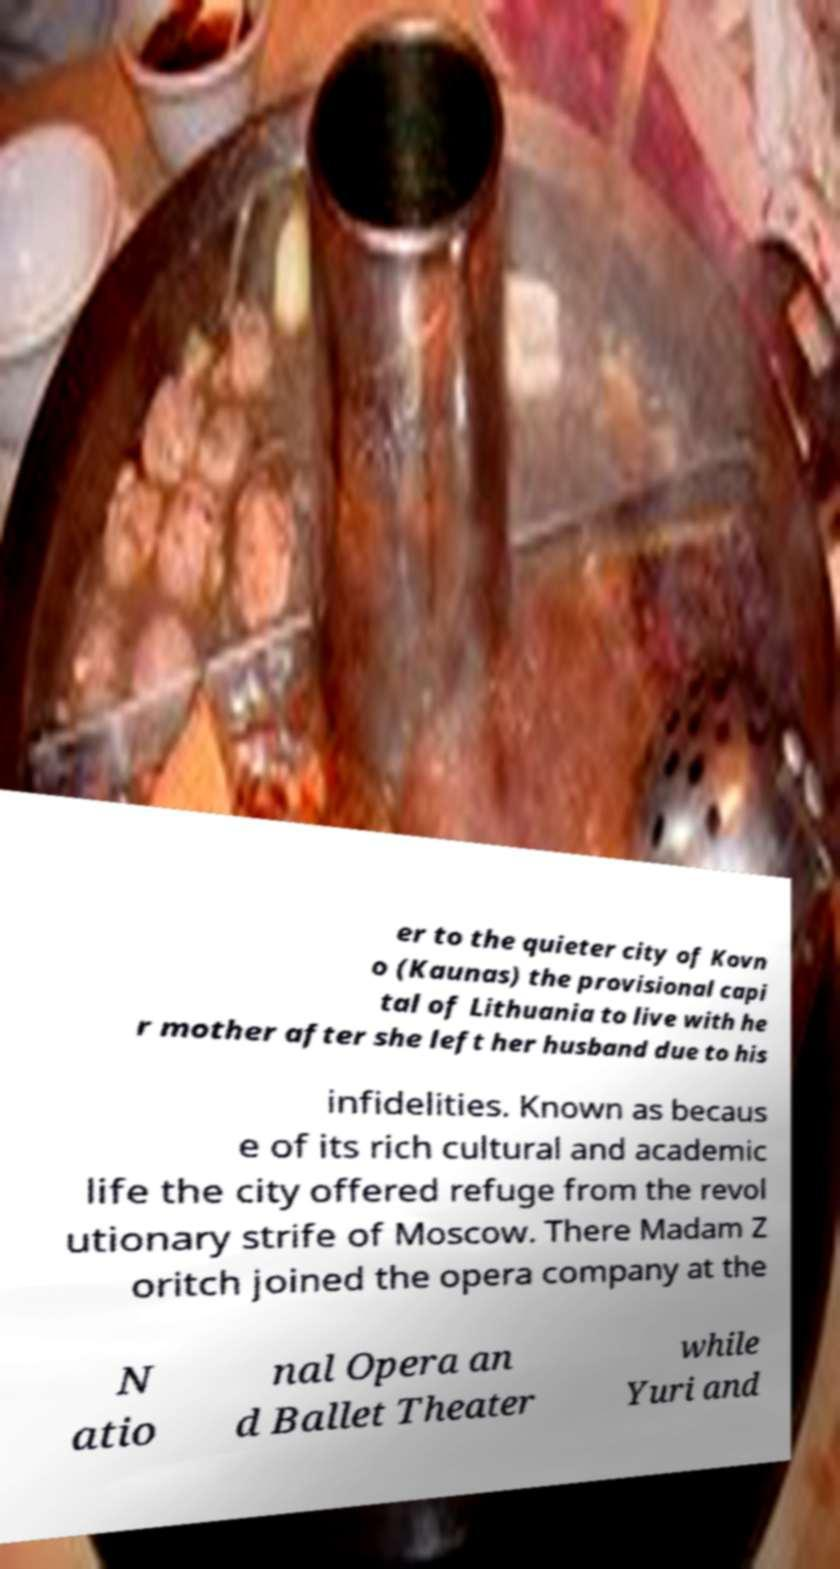Please identify and transcribe the text found in this image. er to the quieter city of Kovn o (Kaunas) the provisional capi tal of Lithuania to live with he r mother after she left her husband due to his infidelities. Known as becaus e of its rich cultural and academic life the city offered refuge from the revol utionary strife of Moscow. There Madam Z oritch joined the opera company at the N atio nal Opera an d Ballet Theater while Yuri and 